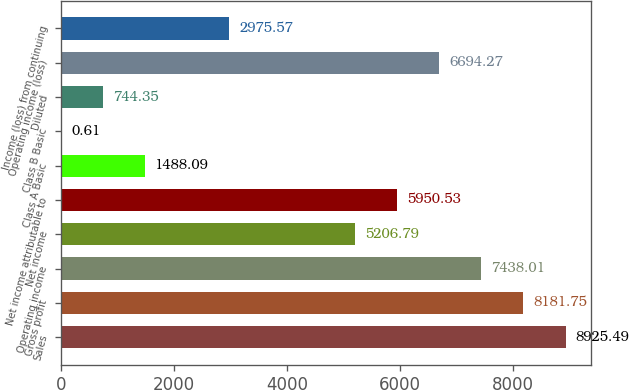Convert chart. <chart><loc_0><loc_0><loc_500><loc_500><bar_chart><fcel>Sales<fcel>Gross profit<fcel>Operating income<fcel>Net income<fcel>Net income attributable to<fcel>Class A Basic<fcel>Class B Basic<fcel>Diluted<fcel>Operating income (loss)<fcel>Income (loss) from continuing<nl><fcel>8925.49<fcel>8181.75<fcel>7438.01<fcel>5206.79<fcel>5950.53<fcel>1488.09<fcel>0.61<fcel>744.35<fcel>6694.27<fcel>2975.57<nl></chart> 